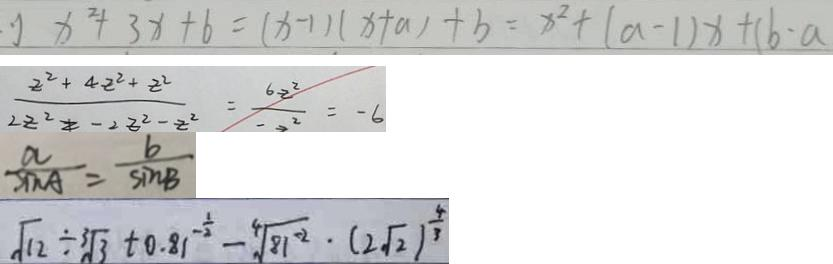<formula> <loc_0><loc_0><loc_500><loc_500>x ^ { 2 } + 3 x + 6 = ( x - 1 ) ( x + a ) + b = x ^ { 2 } + ( a - 1 ) x + ( b - a 
 \frac { 2 ^ { 2 } + 4 - 2 ^ { 2 } + 2 ^ { 2 } } { 2 2 ^ { 2 } } = - 2 ^ { 2 } - z ^ { 2 } = \frac { 6 x ^ { 2 } } { 2 ^ { 2 } } = - 6 
 \frac { a } { \sin A } = \frac { b } { \sin B } 
 \sqrt { 1 2 } \div \sqrt [ 3 ] { 3 } + 0 . 8 1 ^ { - \frac { 1 } { 2 } } - \sqrt [ 4 ] { 8 1 ^ { - 2 } } \cdot ( 2 \sqrt { 2 } ) ^ { \frac { 4 } { 3 } }</formula> 